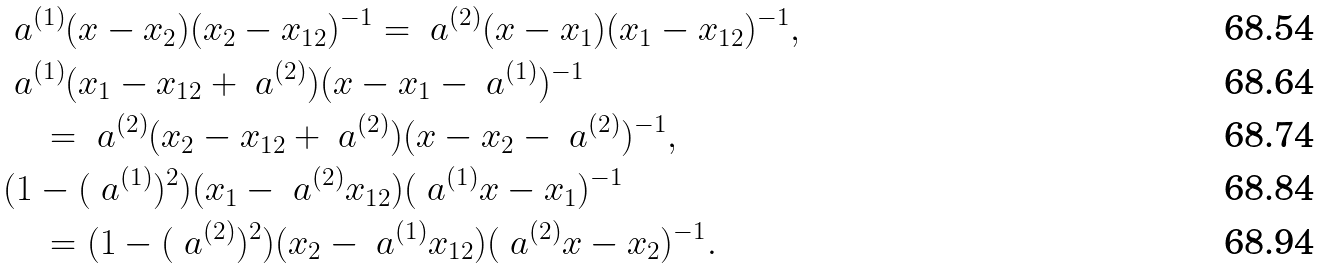Convert formula to latex. <formula><loc_0><loc_0><loc_500><loc_500>& \ a ^ { ( 1 ) } ( x - x _ { 2 } ) ( x _ { 2 } - x _ { 1 2 } ) ^ { - 1 } = \ a ^ { ( 2 ) } ( x - x _ { 1 } ) ( x _ { 1 } - x _ { 1 2 } ) ^ { - 1 } , \\ & \ a ^ { ( 1 ) } ( x _ { 1 } - x _ { 1 2 } + \ a ^ { ( 2 ) } ) ( x - x _ { 1 } - \ a ^ { ( 1 ) } ) ^ { - 1 } \\ & \quad = \ a ^ { ( 2 ) } ( x _ { 2 } - x _ { 1 2 } + \ a ^ { ( 2 ) } ) ( x - x _ { 2 } - \ a ^ { ( 2 ) } ) ^ { - 1 } , \\ & ( 1 - ( \ a ^ { ( 1 ) } ) ^ { 2 } ) ( x _ { 1 } - \ a ^ { ( 2 ) } x _ { 1 2 } ) ( \ a ^ { ( 1 ) } x - x _ { 1 } ) ^ { - 1 } \\ & \quad = ( 1 - ( \ a ^ { ( 2 ) } ) ^ { 2 } ) ( x _ { 2 } - \ a ^ { ( 1 ) } x _ { 1 2 } ) ( \ a ^ { ( 2 ) } x - x _ { 2 } ) ^ { - 1 } .</formula> 